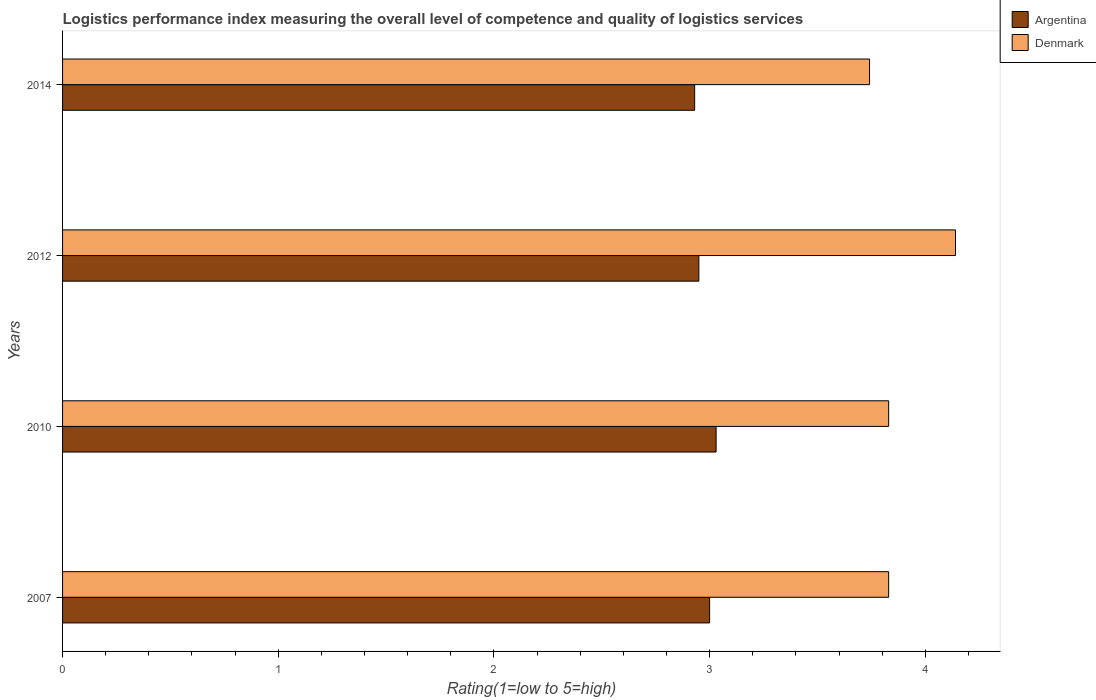Are the number of bars on each tick of the Y-axis equal?
Your response must be concise. Yes. How many bars are there on the 1st tick from the top?
Your answer should be compact. 2. In how many cases, is the number of bars for a given year not equal to the number of legend labels?
Make the answer very short. 0. What is the Logistic performance index in Argentina in 2014?
Make the answer very short. 2.93. Across all years, what is the maximum Logistic performance index in Argentina?
Your response must be concise. 3.03. Across all years, what is the minimum Logistic performance index in Denmark?
Provide a succinct answer. 3.74. In which year was the Logistic performance index in Argentina minimum?
Provide a short and direct response. 2014. What is the total Logistic performance index in Argentina in the graph?
Offer a very short reply. 11.91. What is the difference between the Logistic performance index in Argentina in 2007 and that in 2012?
Provide a succinct answer. 0.05. What is the difference between the Logistic performance index in Argentina in 2014 and the Logistic performance index in Denmark in 2012?
Make the answer very short. -1.21. What is the average Logistic performance index in Denmark per year?
Keep it short and to the point. 3.89. In the year 2014, what is the difference between the Logistic performance index in Denmark and Logistic performance index in Argentina?
Your answer should be very brief. 0.81. Is the Logistic performance index in Argentina in 2007 less than that in 2010?
Your answer should be very brief. Yes. Is the difference between the Logistic performance index in Denmark in 2010 and 2012 greater than the difference between the Logistic performance index in Argentina in 2010 and 2012?
Your response must be concise. No. What is the difference between the highest and the second highest Logistic performance index in Argentina?
Provide a succinct answer. 0.03. What is the difference between the highest and the lowest Logistic performance index in Argentina?
Ensure brevity in your answer.  0.1. In how many years, is the Logistic performance index in Argentina greater than the average Logistic performance index in Argentina taken over all years?
Provide a succinct answer. 2. What does the 2nd bar from the bottom in 2012 represents?
Provide a short and direct response. Denmark. How many bars are there?
Offer a very short reply. 8. Are all the bars in the graph horizontal?
Make the answer very short. Yes. How many years are there in the graph?
Your response must be concise. 4. What is the difference between two consecutive major ticks on the X-axis?
Make the answer very short. 1. Does the graph contain grids?
Provide a succinct answer. No. Where does the legend appear in the graph?
Make the answer very short. Top right. How are the legend labels stacked?
Your answer should be compact. Vertical. What is the title of the graph?
Your answer should be compact. Logistics performance index measuring the overall level of competence and quality of logistics services. What is the label or title of the X-axis?
Keep it short and to the point. Rating(1=low to 5=high). What is the Rating(1=low to 5=high) in Denmark in 2007?
Give a very brief answer. 3.83. What is the Rating(1=low to 5=high) of Argentina in 2010?
Keep it short and to the point. 3.03. What is the Rating(1=low to 5=high) in Denmark in 2010?
Make the answer very short. 3.83. What is the Rating(1=low to 5=high) of Argentina in 2012?
Provide a succinct answer. 2.95. What is the Rating(1=low to 5=high) of Denmark in 2012?
Keep it short and to the point. 4.14. What is the Rating(1=low to 5=high) of Argentina in 2014?
Ensure brevity in your answer.  2.93. What is the Rating(1=low to 5=high) in Denmark in 2014?
Offer a terse response. 3.74. Across all years, what is the maximum Rating(1=low to 5=high) of Argentina?
Offer a very short reply. 3.03. Across all years, what is the maximum Rating(1=low to 5=high) of Denmark?
Provide a short and direct response. 4.14. Across all years, what is the minimum Rating(1=low to 5=high) of Argentina?
Give a very brief answer. 2.93. Across all years, what is the minimum Rating(1=low to 5=high) in Denmark?
Give a very brief answer. 3.74. What is the total Rating(1=low to 5=high) in Argentina in the graph?
Keep it short and to the point. 11.91. What is the total Rating(1=low to 5=high) in Denmark in the graph?
Your answer should be compact. 15.54. What is the difference between the Rating(1=low to 5=high) in Argentina in 2007 and that in 2010?
Provide a succinct answer. -0.03. What is the difference between the Rating(1=low to 5=high) of Denmark in 2007 and that in 2012?
Ensure brevity in your answer.  -0.31. What is the difference between the Rating(1=low to 5=high) of Argentina in 2007 and that in 2014?
Give a very brief answer. 0.07. What is the difference between the Rating(1=low to 5=high) of Denmark in 2007 and that in 2014?
Your answer should be very brief. 0.09. What is the difference between the Rating(1=low to 5=high) of Denmark in 2010 and that in 2012?
Give a very brief answer. -0.31. What is the difference between the Rating(1=low to 5=high) in Argentina in 2010 and that in 2014?
Provide a short and direct response. 0.1. What is the difference between the Rating(1=low to 5=high) of Denmark in 2010 and that in 2014?
Give a very brief answer. 0.09. What is the difference between the Rating(1=low to 5=high) of Argentina in 2012 and that in 2014?
Your response must be concise. 0.02. What is the difference between the Rating(1=low to 5=high) in Denmark in 2012 and that in 2014?
Your answer should be very brief. 0.4. What is the difference between the Rating(1=low to 5=high) of Argentina in 2007 and the Rating(1=low to 5=high) of Denmark in 2010?
Provide a succinct answer. -0.83. What is the difference between the Rating(1=low to 5=high) in Argentina in 2007 and the Rating(1=low to 5=high) in Denmark in 2012?
Your answer should be very brief. -1.14. What is the difference between the Rating(1=low to 5=high) of Argentina in 2007 and the Rating(1=low to 5=high) of Denmark in 2014?
Your response must be concise. -0.74. What is the difference between the Rating(1=low to 5=high) in Argentina in 2010 and the Rating(1=low to 5=high) in Denmark in 2012?
Your response must be concise. -1.11. What is the difference between the Rating(1=low to 5=high) of Argentina in 2010 and the Rating(1=low to 5=high) of Denmark in 2014?
Provide a succinct answer. -0.71. What is the difference between the Rating(1=low to 5=high) of Argentina in 2012 and the Rating(1=low to 5=high) of Denmark in 2014?
Make the answer very short. -0.79. What is the average Rating(1=low to 5=high) of Argentina per year?
Give a very brief answer. 2.98. What is the average Rating(1=low to 5=high) of Denmark per year?
Ensure brevity in your answer.  3.89. In the year 2007, what is the difference between the Rating(1=low to 5=high) of Argentina and Rating(1=low to 5=high) of Denmark?
Keep it short and to the point. -0.83. In the year 2012, what is the difference between the Rating(1=low to 5=high) in Argentina and Rating(1=low to 5=high) in Denmark?
Offer a terse response. -1.19. In the year 2014, what is the difference between the Rating(1=low to 5=high) in Argentina and Rating(1=low to 5=high) in Denmark?
Provide a succinct answer. -0.81. What is the ratio of the Rating(1=low to 5=high) in Argentina in 2007 to that in 2012?
Make the answer very short. 1.02. What is the ratio of the Rating(1=low to 5=high) of Denmark in 2007 to that in 2012?
Offer a very short reply. 0.93. What is the ratio of the Rating(1=low to 5=high) of Argentina in 2007 to that in 2014?
Keep it short and to the point. 1.02. What is the ratio of the Rating(1=low to 5=high) in Denmark in 2007 to that in 2014?
Keep it short and to the point. 1.02. What is the ratio of the Rating(1=low to 5=high) in Argentina in 2010 to that in 2012?
Keep it short and to the point. 1.03. What is the ratio of the Rating(1=low to 5=high) of Denmark in 2010 to that in 2012?
Ensure brevity in your answer.  0.93. What is the ratio of the Rating(1=low to 5=high) in Argentina in 2010 to that in 2014?
Keep it short and to the point. 1.03. What is the ratio of the Rating(1=low to 5=high) in Denmark in 2010 to that in 2014?
Give a very brief answer. 1.02. What is the ratio of the Rating(1=low to 5=high) in Argentina in 2012 to that in 2014?
Provide a succinct answer. 1.01. What is the ratio of the Rating(1=low to 5=high) in Denmark in 2012 to that in 2014?
Offer a very short reply. 1.11. What is the difference between the highest and the second highest Rating(1=low to 5=high) of Argentina?
Give a very brief answer. 0.03. What is the difference between the highest and the second highest Rating(1=low to 5=high) in Denmark?
Offer a terse response. 0.31. What is the difference between the highest and the lowest Rating(1=low to 5=high) of Argentina?
Provide a short and direct response. 0.1. What is the difference between the highest and the lowest Rating(1=low to 5=high) in Denmark?
Make the answer very short. 0.4. 